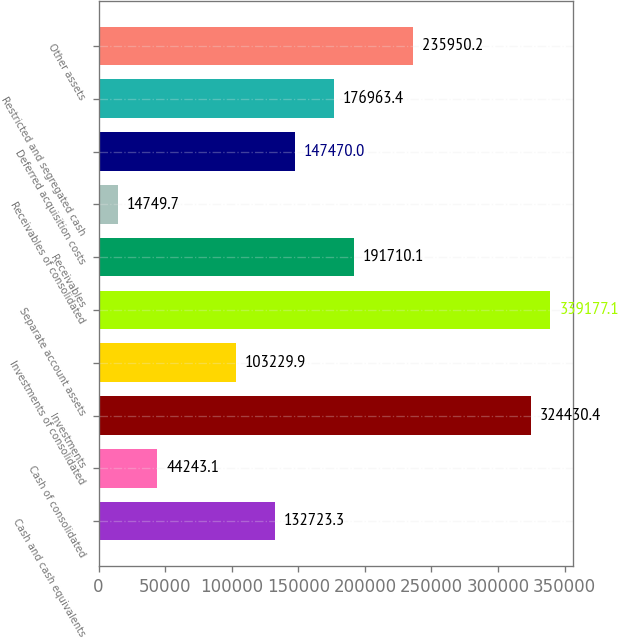Convert chart. <chart><loc_0><loc_0><loc_500><loc_500><bar_chart><fcel>Cash and cash equivalents<fcel>Cash of consolidated<fcel>Investments<fcel>Investments of consolidated<fcel>Separate account assets<fcel>Receivables<fcel>Receivables of consolidated<fcel>Deferred acquisition costs<fcel>Restricted and segregated cash<fcel>Other assets<nl><fcel>132723<fcel>44243.1<fcel>324430<fcel>103230<fcel>339177<fcel>191710<fcel>14749.7<fcel>147470<fcel>176963<fcel>235950<nl></chart> 